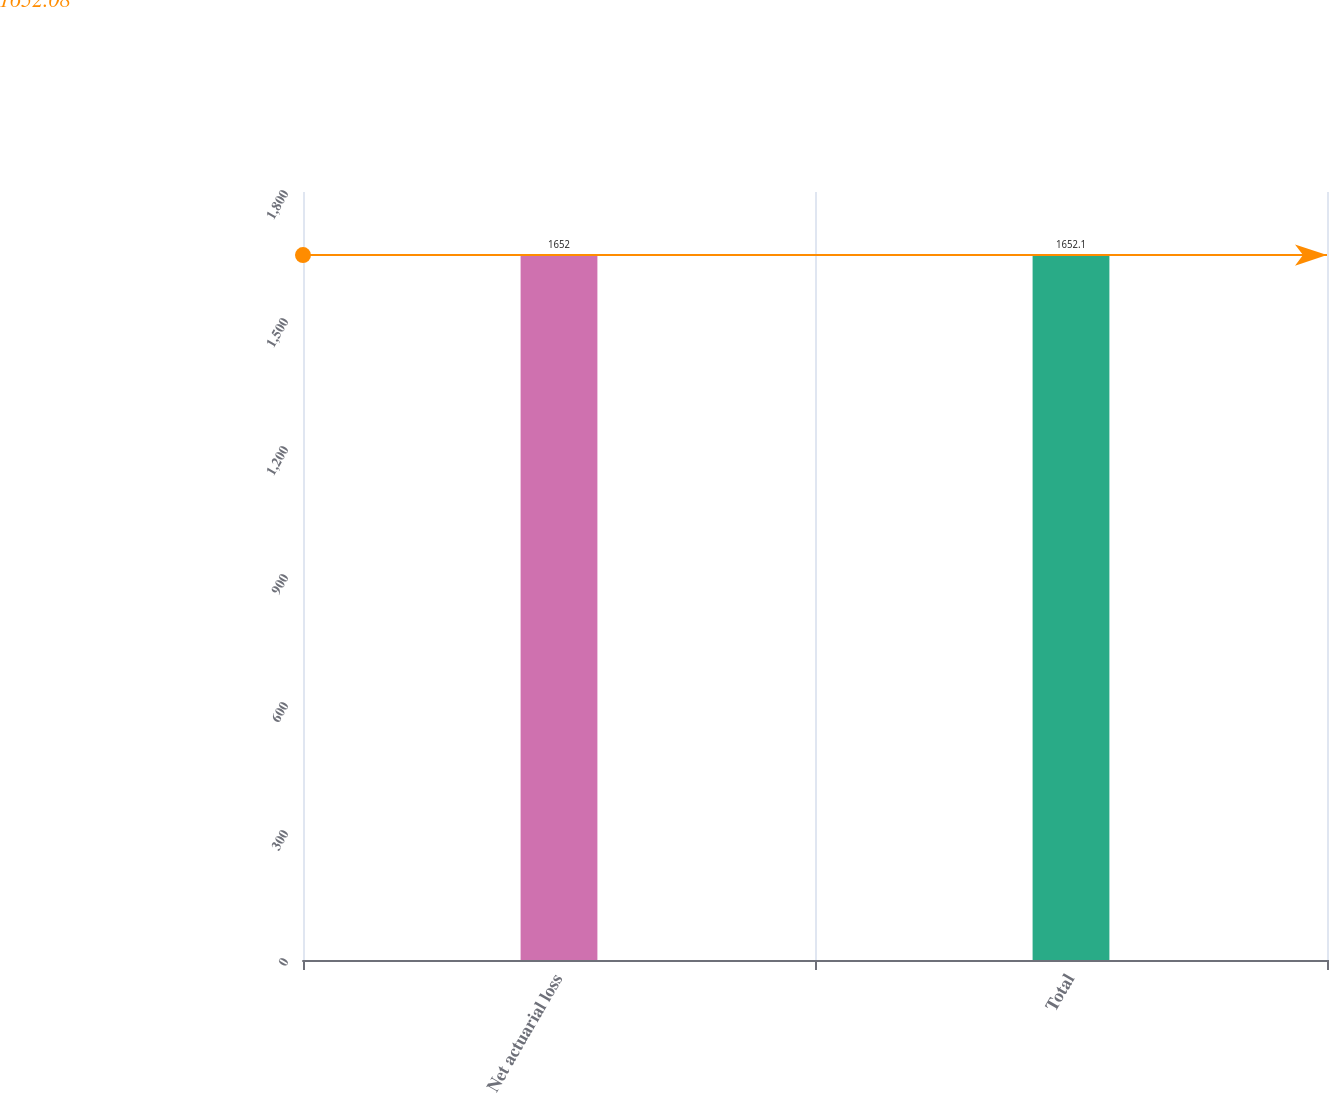Convert chart. <chart><loc_0><loc_0><loc_500><loc_500><bar_chart><fcel>Net actuarial loss<fcel>Total<nl><fcel>1652<fcel>1652.1<nl></chart> 